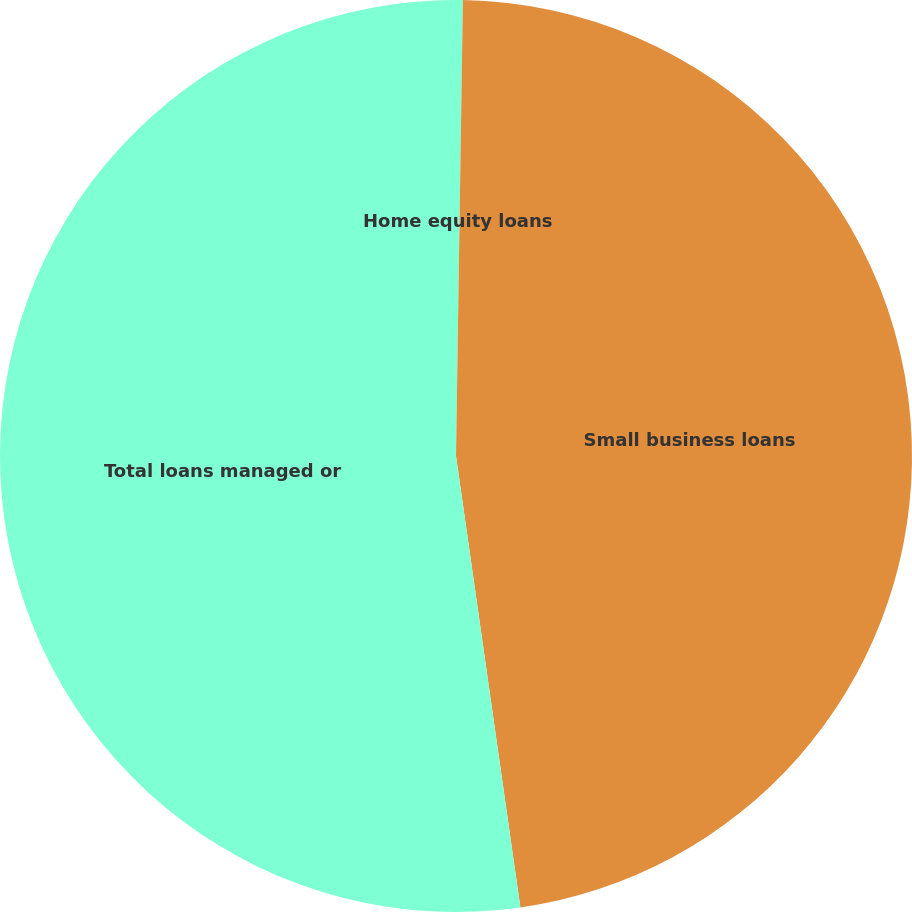Convert chart to OTSL. <chart><loc_0><loc_0><loc_500><loc_500><pie_chart><fcel>Home equity loans<fcel>Small business loans<fcel>Total loans managed or<nl><fcel>0.24%<fcel>47.5%<fcel>52.25%<nl></chart> 